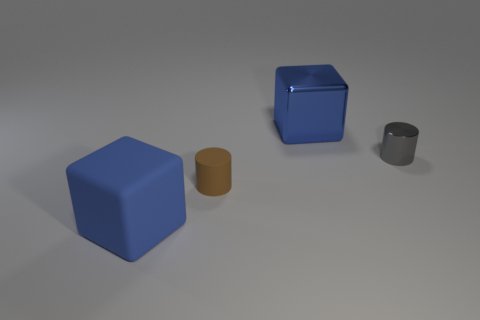Add 3 cyan cylinders. How many objects exist? 7 Subtract all small matte cubes. Subtract all large metallic blocks. How many objects are left? 3 Add 1 brown objects. How many brown objects are left? 2 Add 1 big red spheres. How many big red spheres exist? 1 Subtract 0 brown blocks. How many objects are left? 4 